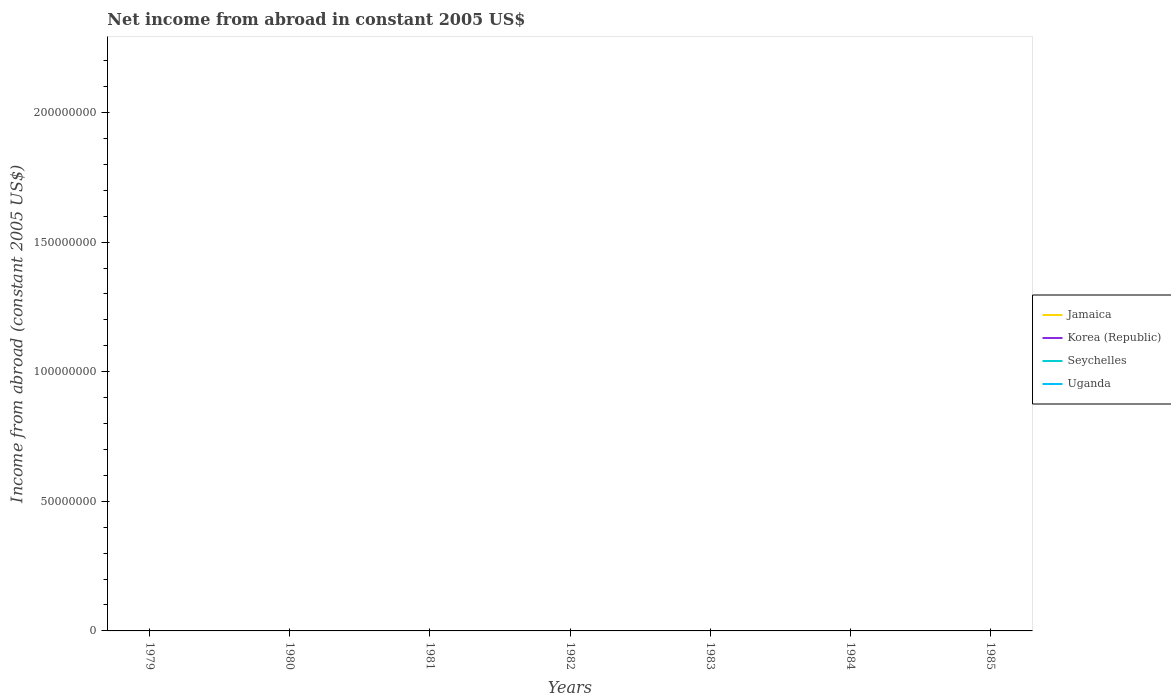How many different coloured lines are there?
Your response must be concise. 0. Does the line corresponding to Seychelles intersect with the line corresponding to Korea (Republic)?
Your answer should be very brief. No. Is the number of lines equal to the number of legend labels?
Make the answer very short. No. Across all years, what is the maximum net income from abroad in Korea (Republic)?
Provide a short and direct response. 0. Is the net income from abroad in Seychelles strictly greater than the net income from abroad in Uganda over the years?
Provide a succinct answer. No. What is the difference between two consecutive major ticks on the Y-axis?
Keep it short and to the point. 5.00e+07. Are the values on the major ticks of Y-axis written in scientific E-notation?
Make the answer very short. No. Does the graph contain grids?
Keep it short and to the point. No. What is the title of the graph?
Give a very brief answer. Net income from abroad in constant 2005 US$. What is the label or title of the X-axis?
Offer a terse response. Years. What is the label or title of the Y-axis?
Provide a succinct answer. Income from abroad (constant 2005 US$). What is the Income from abroad (constant 2005 US$) in Korea (Republic) in 1979?
Provide a short and direct response. 0. What is the Income from abroad (constant 2005 US$) of Seychelles in 1979?
Your response must be concise. 0. What is the Income from abroad (constant 2005 US$) in Uganda in 1979?
Give a very brief answer. 0. What is the Income from abroad (constant 2005 US$) in Jamaica in 1981?
Your answer should be compact. 0. What is the Income from abroad (constant 2005 US$) of Seychelles in 1982?
Your response must be concise. 0. What is the Income from abroad (constant 2005 US$) of Uganda in 1982?
Your answer should be compact. 0. What is the Income from abroad (constant 2005 US$) in Seychelles in 1983?
Your answer should be compact. 0. What is the Income from abroad (constant 2005 US$) in Uganda in 1983?
Offer a terse response. 0. What is the Income from abroad (constant 2005 US$) of Seychelles in 1984?
Offer a very short reply. 0. What is the Income from abroad (constant 2005 US$) in Jamaica in 1985?
Make the answer very short. 0. What is the Income from abroad (constant 2005 US$) of Korea (Republic) in 1985?
Provide a short and direct response. 0. What is the total Income from abroad (constant 2005 US$) of Korea (Republic) in the graph?
Provide a succinct answer. 0. What is the total Income from abroad (constant 2005 US$) of Seychelles in the graph?
Ensure brevity in your answer.  0. What is the total Income from abroad (constant 2005 US$) of Uganda in the graph?
Ensure brevity in your answer.  0. What is the average Income from abroad (constant 2005 US$) of Korea (Republic) per year?
Offer a very short reply. 0. What is the average Income from abroad (constant 2005 US$) in Uganda per year?
Provide a succinct answer. 0. 